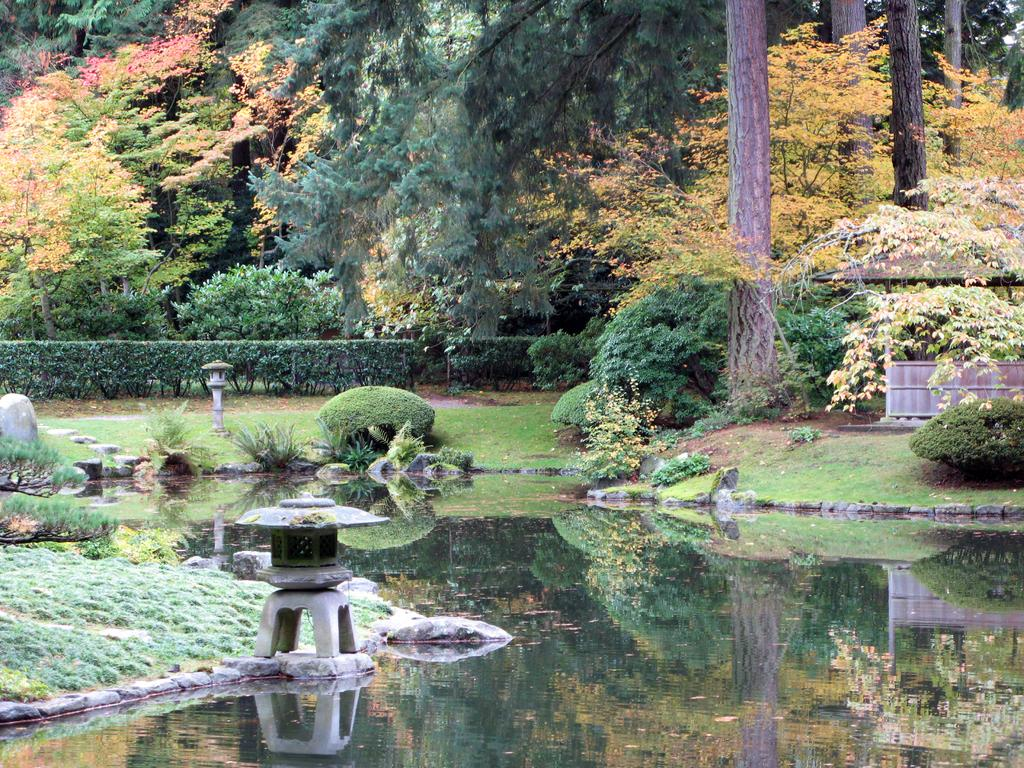What is one of the main elements in the image? There is water in the image. What type of vegetation can be seen in the image? There is grass and plants in the image. What is visible on the ground in the image? The ground is visible in the image. What can be seen in the background of the image? There are trees in the background of the image. What colors are present on the trees in the image? The trees have green, orange, and pink colors. What direction is the boy facing in the image? There is no boy present in the image. What type of fuel is being used by the plants in the image? Plants do not use fuel; they produce their own energy through photosynthesis. 